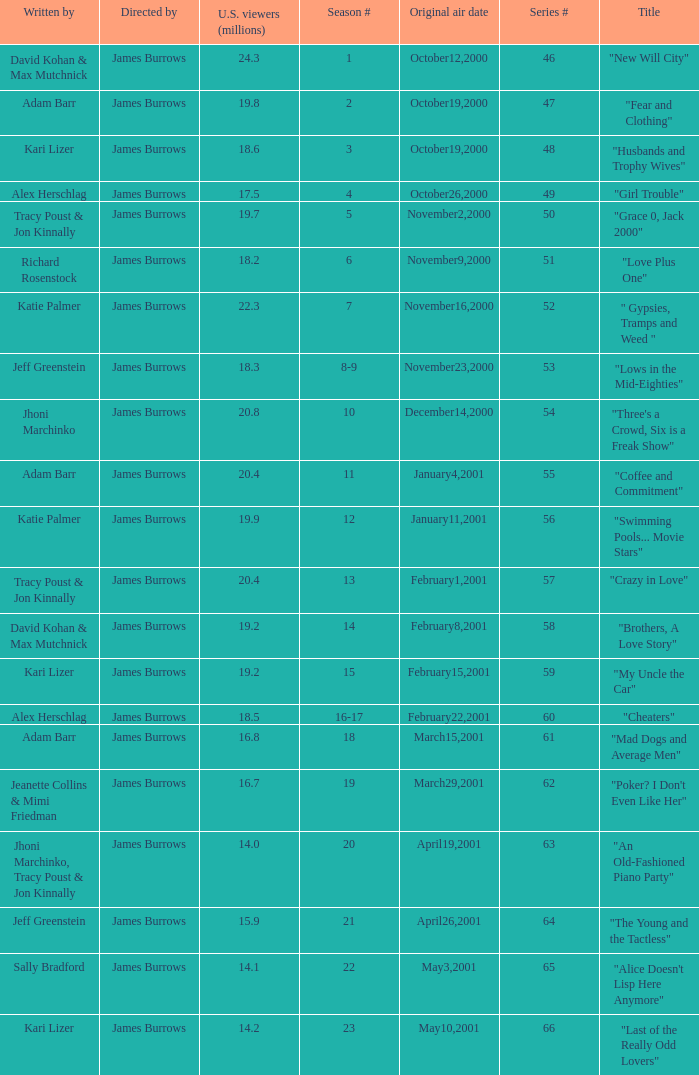Who wrote the episode titled "An Old-fashioned Piano Party"? Jhoni Marchinko, Tracy Poust & Jon Kinnally. 